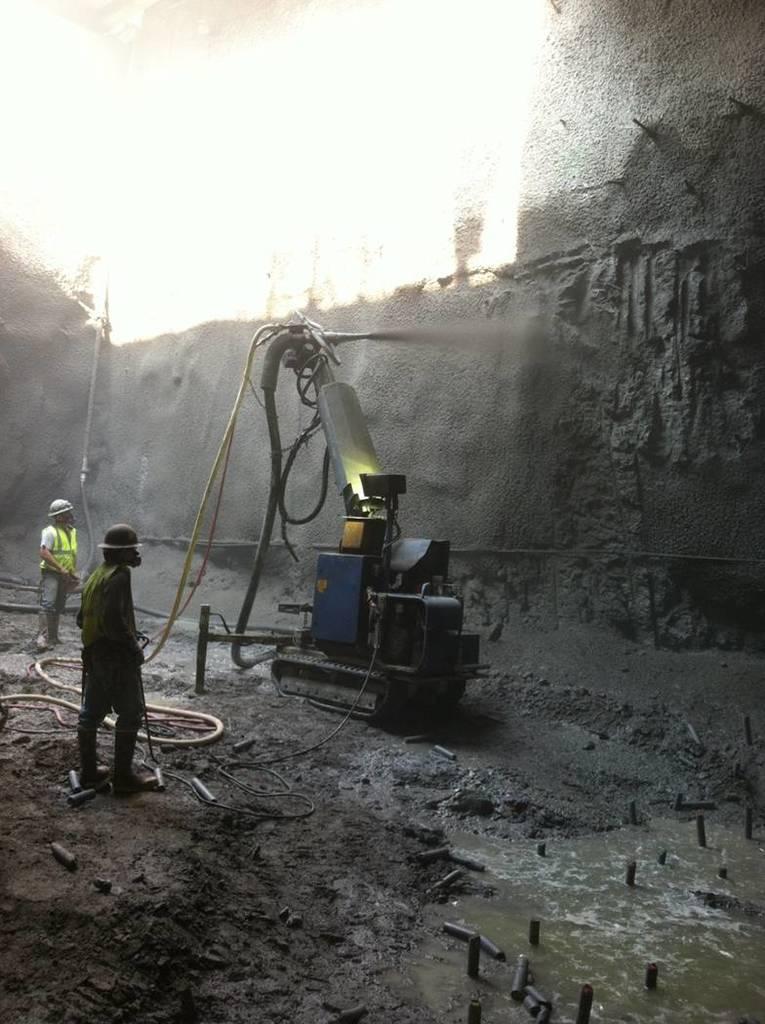Describe this image in one or two sentences. In this image in the front there is water. In the center there is a machine and there are persons standing. In the background there is a wall. 